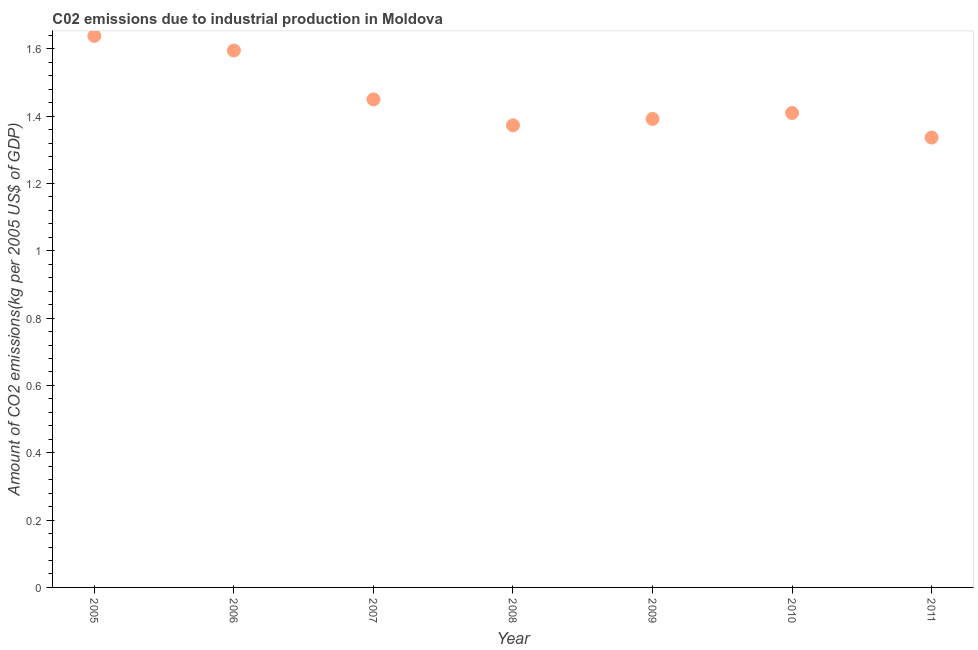What is the amount of co2 emissions in 2011?
Your answer should be compact. 1.34. Across all years, what is the maximum amount of co2 emissions?
Keep it short and to the point. 1.64. Across all years, what is the minimum amount of co2 emissions?
Your answer should be compact. 1.34. In which year was the amount of co2 emissions maximum?
Make the answer very short. 2005. In which year was the amount of co2 emissions minimum?
Give a very brief answer. 2011. What is the sum of the amount of co2 emissions?
Keep it short and to the point. 10.19. What is the difference between the amount of co2 emissions in 2006 and 2007?
Provide a succinct answer. 0.15. What is the average amount of co2 emissions per year?
Provide a short and direct response. 1.46. What is the median amount of co2 emissions?
Offer a very short reply. 1.41. What is the ratio of the amount of co2 emissions in 2008 to that in 2009?
Your response must be concise. 0.99. Is the difference between the amount of co2 emissions in 2007 and 2010 greater than the difference between any two years?
Give a very brief answer. No. What is the difference between the highest and the second highest amount of co2 emissions?
Provide a short and direct response. 0.04. What is the difference between the highest and the lowest amount of co2 emissions?
Your response must be concise. 0.3. In how many years, is the amount of co2 emissions greater than the average amount of co2 emissions taken over all years?
Ensure brevity in your answer.  2. What is the difference between two consecutive major ticks on the Y-axis?
Your answer should be very brief. 0.2. Are the values on the major ticks of Y-axis written in scientific E-notation?
Ensure brevity in your answer.  No. Does the graph contain any zero values?
Ensure brevity in your answer.  No. What is the title of the graph?
Provide a succinct answer. C02 emissions due to industrial production in Moldova. What is the label or title of the X-axis?
Provide a succinct answer. Year. What is the label or title of the Y-axis?
Offer a terse response. Amount of CO2 emissions(kg per 2005 US$ of GDP). What is the Amount of CO2 emissions(kg per 2005 US$ of GDP) in 2005?
Your answer should be very brief. 1.64. What is the Amount of CO2 emissions(kg per 2005 US$ of GDP) in 2006?
Keep it short and to the point. 1.59. What is the Amount of CO2 emissions(kg per 2005 US$ of GDP) in 2007?
Give a very brief answer. 1.45. What is the Amount of CO2 emissions(kg per 2005 US$ of GDP) in 2008?
Offer a terse response. 1.37. What is the Amount of CO2 emissions(kg per 2005 US$ of GDP) in 2009?
Ensure brevity in your answer.  1.39. What is the Amount of CO2 emissions(kg per 2005 US$ of GDP) in 2010?
Provide a short and direct response. 1.41. What is the Amount of CO2 emissions(kg per 2005 US$ of GDP) in 2011?
Make the answer very short. 1.34. What is the difference between the Amount of CO2 emissions(kg per 2005 US$ of GDP) in 2005 and 2006?
Provide a short and direct response. 0.04. What is the difference between the Amount of CO2 emissions(kg per 2005 US$ of GDP) in 2005 and 2007?
Your response must be concise. 0.19. What is the difference between the Amount of CO2 emissions(kg per 2005 US$ of GDP) in 2005 and 2008?
Offer a terse response. 0.27. What is the difference between the Amount of CO2 emissions(kg per 2005 US$ of GDP) in 2005 and 2009?
Your answer should be compact. 0.25. What is the difference between the Amount of CO2 emissions(kg per 2005 US$ of GDP) in 2005 and 2010?
Your answer should be very brief. 0.23. What is the difference between the Amount of CO2 emissions(kg per 2005 US$ of GDP) in 2005 and 2011?
Provide a succinct answer. 0.3. What is the difference between the Amount of CO2 emissions(kg per 2005 US$ of GDP) in 2006 and 2007?
Keep it short and to the point. 0.15. What is the difference between the Amount of CO2 emissions(kg per 2005 US$ of GDP) in 2006 and 2008?
Provide a short and direct response. 0.22. What is the difference between the Amount of CO2 emissions(kg per 2005 US$ of GDP) in 2006 and 2009?
Make the answer very short. 0.2. What is the difference between the Amount of CO2 emissions(kg per 2005 US$ of GDP) in 2006 and 2010?
Offer a very short reply. 0.19. What is the difference between the Amount of CO2 emissions(kg per 2005 US$ of GDP) in 2006 and 2011?
Offer a very short reply. 0.26. What is the difference between the Amount of CO2 emissions(kg per 2005 US$ of GDP) in 2007 and 2008?
Ensure brevity in your answer.  0.08. What is the difference between the Amount of CO2 emissions(kg per 2005 US$ of GDP) in 2007 and 2009?
Provide a succinct answer. 0.06. What is the difference between the Amount of CO2 emissions(kg per 2005 US$ of GDP) in 2007 and 2010?
Provide a short and direct response. 0.04. What is the difference between the Amount of CO2 emissions(kg per 2005 US$ of GDP) in 2007 and 2011?
Your answer should be compact. 0.11. What is the difference between the Amount of CO2 emissions(kg per 2005 US$ of GDP) in 2008 and 2009?
Make the answer very short. -0.02. What is the difference between the Amount of CO2 emissions(kg per 2005 US$ of GDP) in 2008 and 2010?
Offer a terse response. -0.04. What is the difference between the Amount of CO2 emissions(kg per 2005 US$ of GDP) in 2008 and 2011?
Ensure brevity in your answer.  0.04. What is the difference between the Amount of CO2 emissions(kg per 2005 US$ of GDP) in 2009 and 2010?
Give a very brief answer. -0.02. What is the difference between the Amount of CO2 emissions(kg per 2005 US$ of GDP) in 2009 and 2011?
Offer a very short reply. 0.06. What is the difference between the Amount of CO2 emissions(kg per 2005 US$ of GDP) in 2010 and 2011?
Your response must be concise. 0.07. What is the ratio of the Amount of CO2 emissions(kg per 2005 US$ of GDP) in 2005 to that in 2007?
Make the answer very short. 1.13. What is the ratio of the Amount of CO2 emissions(kg per 2005 US$ of GDP) in 2005 to that in 2008?
Ensure brevity in your answer.  1.19. What is the ratio of the Amount of CO2 emissions(kg per 2005 US$ of GDP) in 2005 to that in 2009?
Ensure brevity in your answer.  1.18. What is the ratio of the Amount of CO2 emissions(kg per 2005 US$ of GDP) in 2005 to that in 2010?
Your answer should be very brief. 1.16. What is the ratio of the Amount of CO2 emissions(kg per 2005 US$ of GDP) in 2005 to that in 2011?
Your response must be concise. 1.23. What is the ratio of the Amount of CO2 emissions(kg per 2005 US$ of GDP) in 2006 to that in 2008?
Give a very brief answer. 1.16. What is the ratio of the Amount of CO2 emissions(kg per 2005 US$ of GDP) in 2006 to that in 2009?
Ensure brevity in your answer.  1.15. What is the ratio of the Amount of CO2 emissions(kg per 2005 US$ of GDP) in 2006 to that in 2010?
Your answer should be compact. 1.13. What is the ratio of the Amount of CO2 emissions(kg per 2005 US$ of GDP) in 2006 to that in 2011?
Make the answer very short. 1.19. What is the ratio of the Amount of CO2 emissions(kg per 2005 US$ of GDP) in 2007 to that in 2008?
Your answer should be very brief. 1.06. What is the ratio of the Amount of CO2 emissions(kg per 2005 US$ of GDP) in 2007 to that in 2009?
Make the answer very short. 1.04. What is the ratio of the Amount of CO2 emissions(kg per 2005 US$ of GDP) in 2007 to that in 2010?
Ensure brevity in your answer.  1.03. What is the ratio of the Amount of CO2 emissions(kg per 2005 US$ of GDP) in 2007 to that in 2011?
Provide a short and direct response. 1.08. What is the ratio of the Amount of CO2 emissions(kg per 2005 US$ of GDP) in 2008 to that in 2009?
Make the answer very short. 0.99. What is the ratio of the Amount of CO2 emissions(kg per 2005 US$ of GDP) in 2008 to that in 2010?
Your answer should be compact. 0.97. What is the ratio of the Amount of CO2 emissions(kg per 2005 US$ of GDP) in 2008 to that in 2011?
Offer a terse response. 1.03. What is the ratio of the Amount of CO2 emissions(kg per 2005 US$ of GDP) in 2009 to that in 2010?
Offer a very short reply. 0.99. What is the ratio of the Amount of CO2 emissions(kg per 2005 US$ of GDP) in 2009 to that in 2011?
Your answer should be compact. 1.04. What is the ratio of the Amount of CO2 emissions(kg per 2005 US$ of GDP) in 2010 to that in 2011?
Keep it short and to the point. 1.05. 